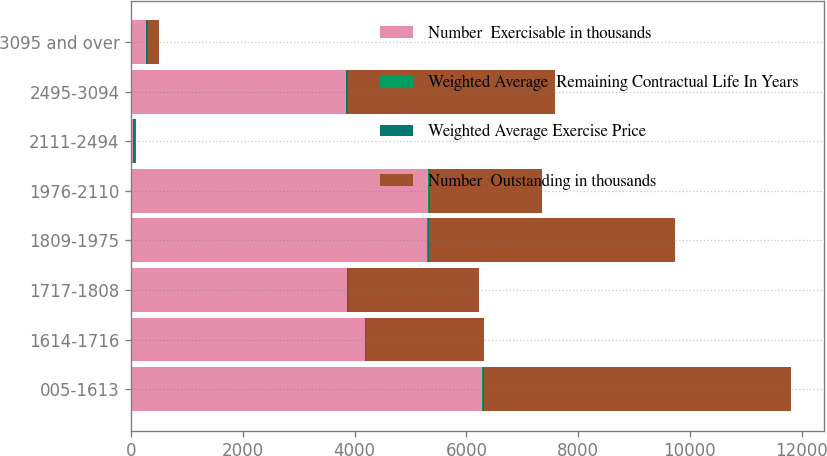<chart> <loc_0><loc_0><loc_500><loc_500><stacked_bar_chart><ecel><fcel>005-1613<fcel>1614-1716<fcel>1717-1808<fcel>1809-1975<fcel>1976-2110<fcel>2111-2494<fcel>2495-3094<fcel>3095 and over<nl><fcel>Number  Exercisable in thousands<fcel>6287<fcel>4186<fcel>3859<fcel>5302<fcel>5316<fcel>30.63<fcel>3845<fcel>257<nl><fcel>Weighted Average  Remaining Contractual Life In Years<fcel>4.41<fcel>4.91<fcel>4.79<fcel>3.71<fcel>6.05<fcel>4.64<fcel>4.58<fcel>6.79<nl><fcel>Weighted Average Exercise Price<fcel>14.87<fcel>17.07<fcel>17.71<fcel>19.14<fcel>20.73<fcel>22.94<fcel>28.42<fcel>32.84<nl><fcel>Number  Outstanding in thousands<fcel>5501<fcel>2103<fcel>2337<fcel>4414<fcel>2011<fcel>30.63<fcel>3715<fcel>194<nl></chart> 